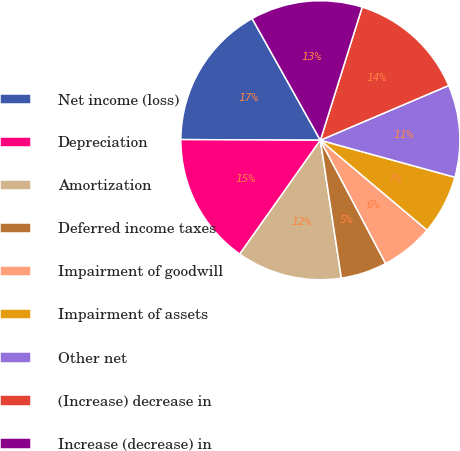Convert chart. <chart><loc_0><loc_0><loc_500><loc_500><pie_chart><fcel>Net income (loss)<fcel>Depreciation<fcel>Amortization<fcel>Deferred income taxes<fcel>Impairment of goodwill<fcel>Impairment of assets<fcel>Other net<fcel>(Increase) decrease in<fcel>Increase (decrease) in<nl><fcel>16.79%<fcel>15.27%<fcel>12.21%<fcel>5.34%<fcel>6.11%<fcel>6.87%<fcel>10.69%<fcel>13.74%<fcel>12.98%<nl></chart> 